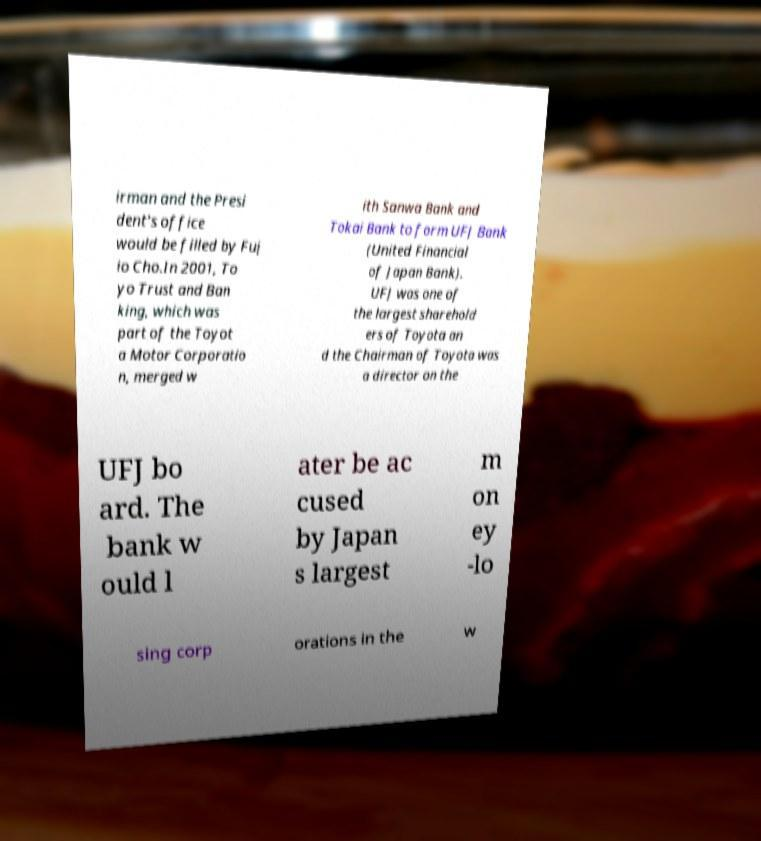Could you extract and type out the text from this image? irman and the Presi dent's office would be filled by Fuj io Cho.In 2001, To yo Trust and Ban king, which was part of the Toyot a Motor Corporatio n, merged w ith Sanwa Bank and Tokai Bank to form UFJ Bank (United Financial of Japan Bank). UFJ was one of the largest sharehold ers of Toyota an d the Chairman of Toyota was a director on the UFJ bo ard. The bank w ould l ater be ac cused by Japan s largest m on ey -lo sing corp orations in the w 